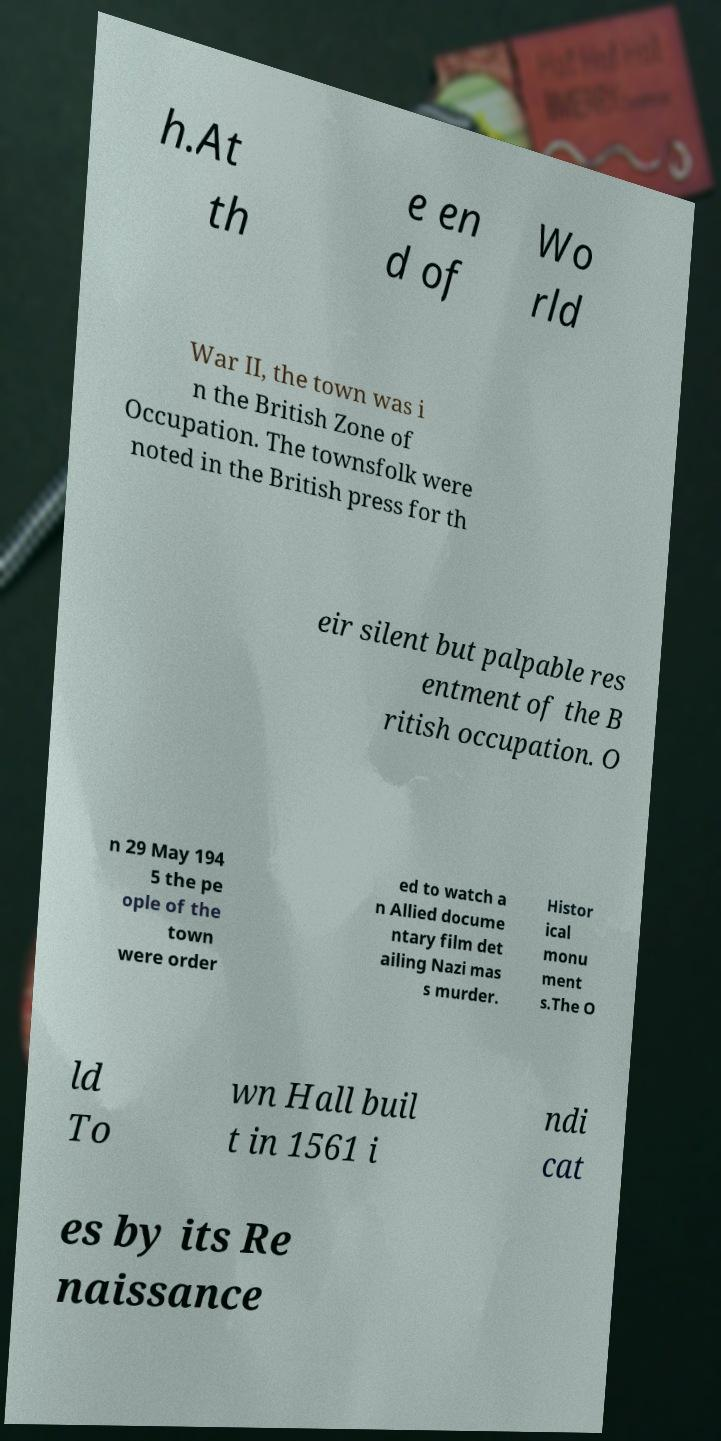There's text embedded in this image that I need extracted. Can you transcribe it verbatim? h.At th e en d of Wo rld War II, the town was i n the British Zone of Occupation. The townsfolk were noted in the British press for th eir silent but palpable res entment of the B ritish occupation. O n 29 May 194 5 the pe ople of the town were order ed to watch a n Allied docume ntary film det ailing Nazi mas s murder. Histor ical monu ment s.The O ld To wn Hall buil t in 1561 i ndi cat es by its Re naissance 